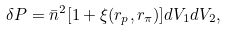Convert formula to latex. <formula><loc_0><loc_0><loc_500><loc_500>\delta P = \bar { n } ^ { 2 } [ 1 + \xi ( r _ { p } , r _ { \pi } ) ] d V _ { 1 } d V _ { 2 } ,</formula> 